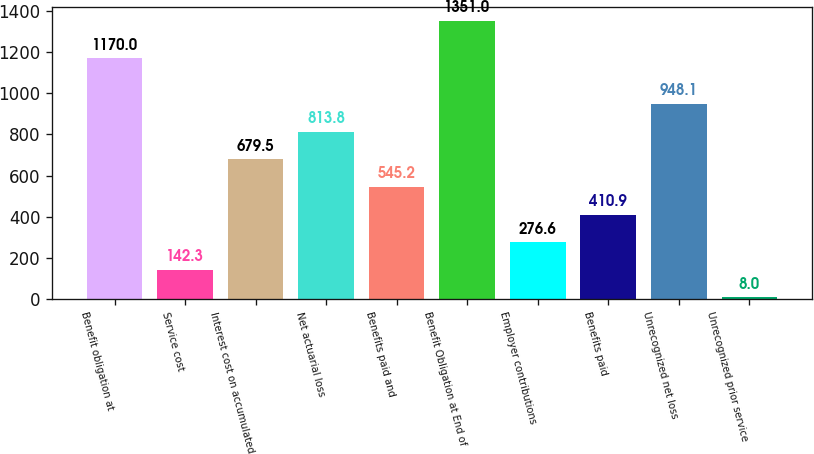Convert chart. <chart><loc_0><loc_0><loc_500><loc_500><bar_chart><fcel>Benefit obligation at<fcel>Service cost<fcel>Interest cost on accumulated<fcel>Net actuarial loss<fcel>Benefits paid and<fcel>Benefit Obligation at End of<fcel>Employer contributions<fcel>Benefits paid<fcel>Unrecognized net loss<fcel>Unrecognized prior service<nl><fcel>1170<fcel>142.3<fcel>679.5<fcel>813.8<fcel>545.2<fcel>1351<fcel>276.6<fcel>410.9<fcel>948.1<fcel>8<nl></chart> 